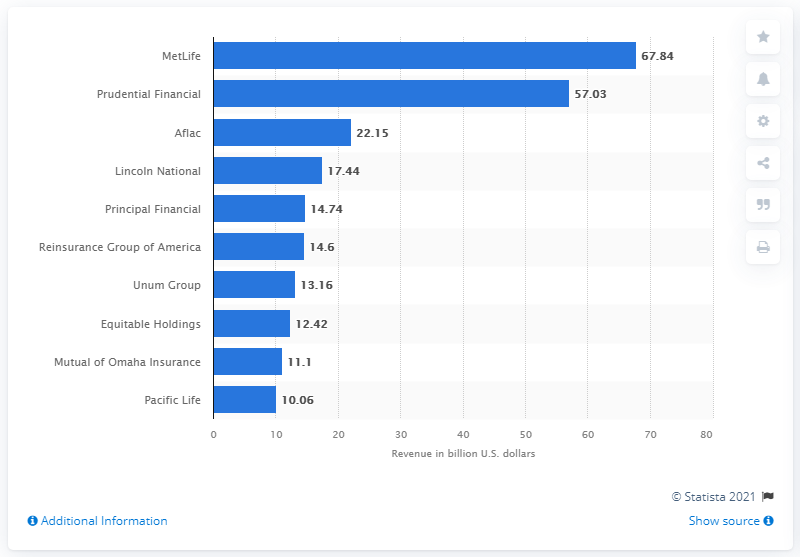Draw attention to some important aspects in this diagram. MetLife's revenue in dollars in 2020 was approximately $67.84 billion. 